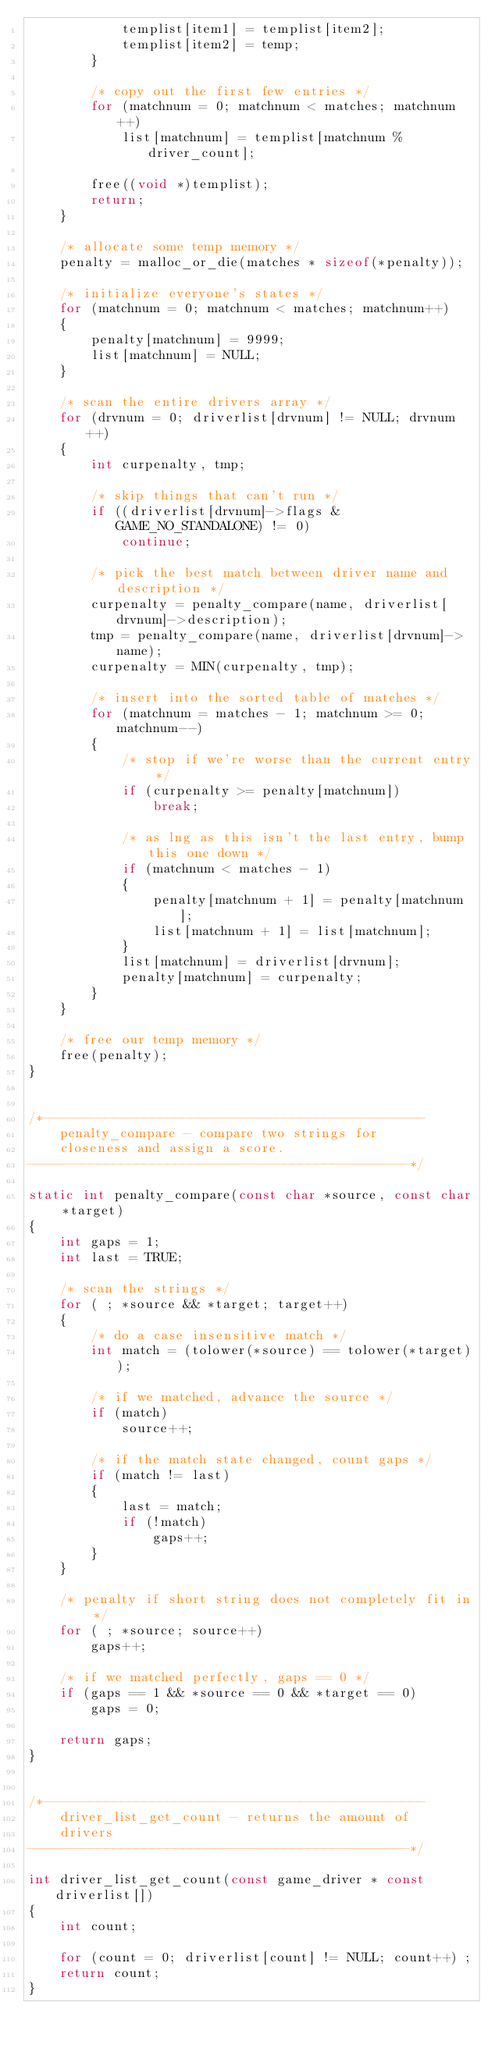<code> <loc_0><loc_0><loc_500><loc_500><_C_>			templist[item1] = templist[item2];
			templist[item2] = temp;
		}

		/* copy out the first few entries */
		for (matchnum = 0; matchnum < matches; matchnum++)
			list[matchnum] = templist[matchnum % driver_count];

		free((void *)templist);
		return;
	}

	/* allocate some temp memory */
	penalty = malloc_or_die(matches * sizeof(*penalty));

	/* initialize everyone's states */
	for (matchnum = 0; matchnum < matches; matchnum++)
	{
		penalty[matchnum] = 9999;
		list[matchnum] = NULL;
	}

	/* scan the entire drivers array */
	for (drvnum = 0; driverlist[drvnum] != NULL; drvnum++)
	{
		int curpenalty, tmp;

		/* skip things that can't run */
		if ((driverlist[drvnum]->flags & GAME_NO_STANDALONE) != 0)
			continue;

		/* pick the best match between driver name and description */
		curpenalty = penalty_compare(name, driverlist[drvnum]->description);
		tmp = penalty_compare(name, driverlist[drvnum]->name);
		curpenalty = MIN(curpenalty, tmp);

		/* insert into the sorted table of matches */
		for (matchnum = matches - 1; matchnum >= 0; matchnum--)
		{
			/* stop if we're worse than the current entry */
			if (curpenalty >= penalty[matchnum])
				break;

			/* as lng as this isn't the last entry, bump this one down */
			if (matchnum < matches - 1)
			{
				penalty[matchnum + 1] = penalty[matchnum];
				list[matchnum + 1] = list[matchnum];
			}
			list[matchnum] = driverlist[drvnum];
			penalty[matchnum] = curpenalty;
		}
	}

	/* free our temp memory */
	free(penalty);
}


/*-------------------------------------------------
    penalty_compare - compare two strings for
    closeness and assign a score.
-------------------------------------------------*/

static int penalty_compare(const char *source, const char *target)
{
	int gaps = 1;
	int last = TRUE;

	/* scan the strings */
	for ( ; *source && *target; target++)
	{
		/* do a case insensitive match */
		int match = (tolower(*source) == tolower(*target));

		/* if we matched, advance the source */
		if (match)
			source++;

		/* if the match state changed, count gaps */
		if (match != last)
		{
			last = match;
			if (!match)
				gaps++;
		}
	}

	/* penalty if short string does not completely fit in */
	for ( ; *source; source++)
		gaps++;

	/* if we matched perfectly, gaps == 0 */
	if (gaps == 1 && *source == 0 && *target == 0)
		gaps = 0;

	return gaps;
}


/*-------------------------------------------------
    driver_list_get_count - returns the amount of
    drivers
-------------------------------------------------*/

int driver_list_get_count(const game_driver * const driverlist[])
{
	int count;

	for (count = 0; driverlist[count] != NULL; count++) ;
	return count;
}
</code> 